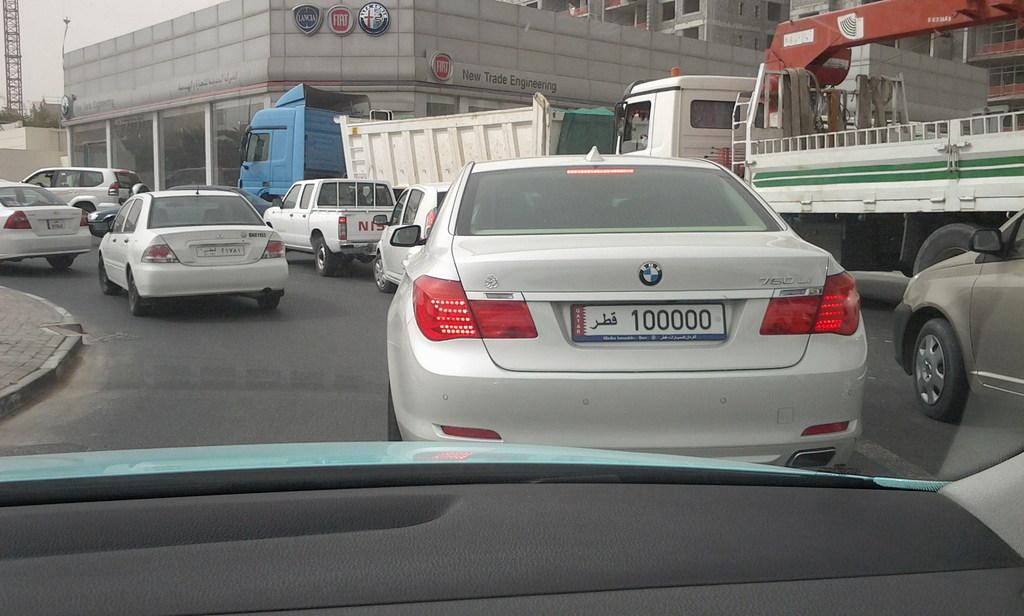Provide a one-sentence caption for the provided image. A white BMW that has the numbers 100000 on the license plate drives amongst several other vehicles. 